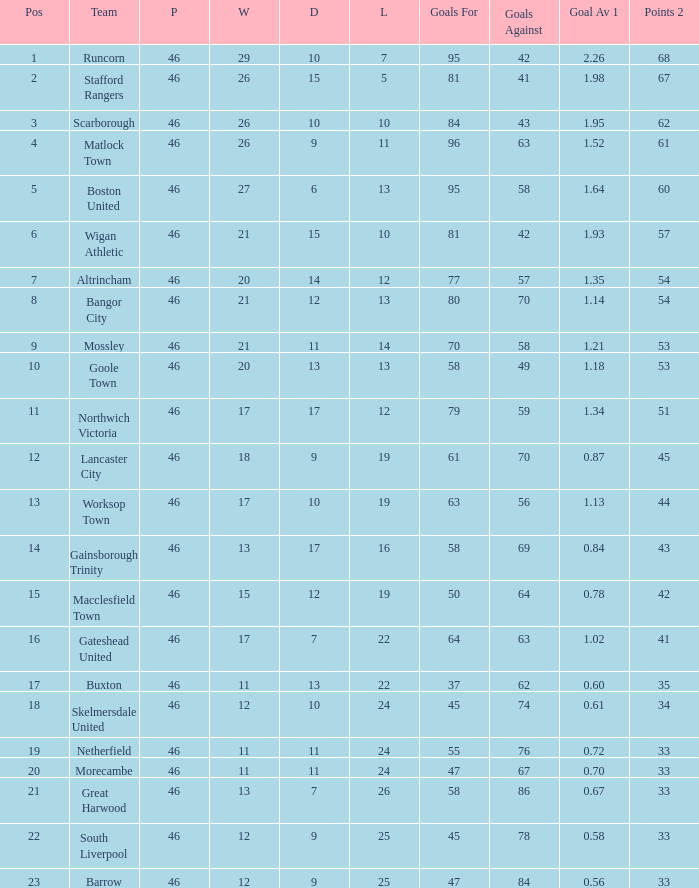List all losses with average goals of 1.21. 14.0. 